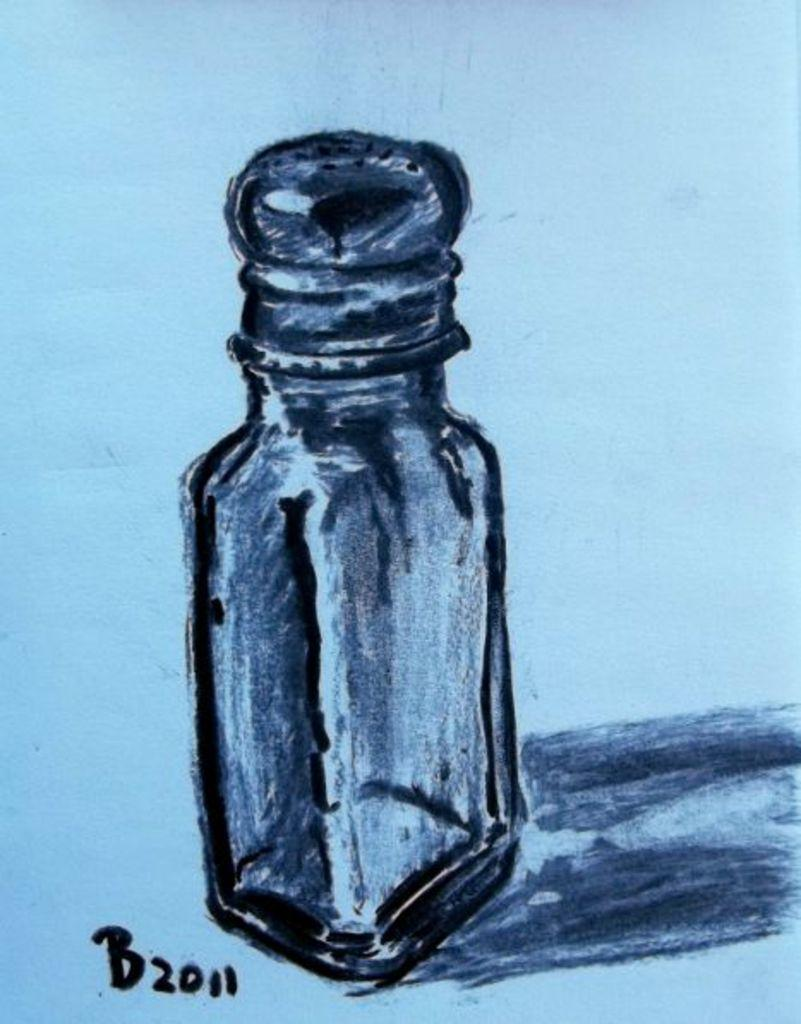<image>
Provide a brief description of the given image. A drawing of a salt shaker with the date 2011 